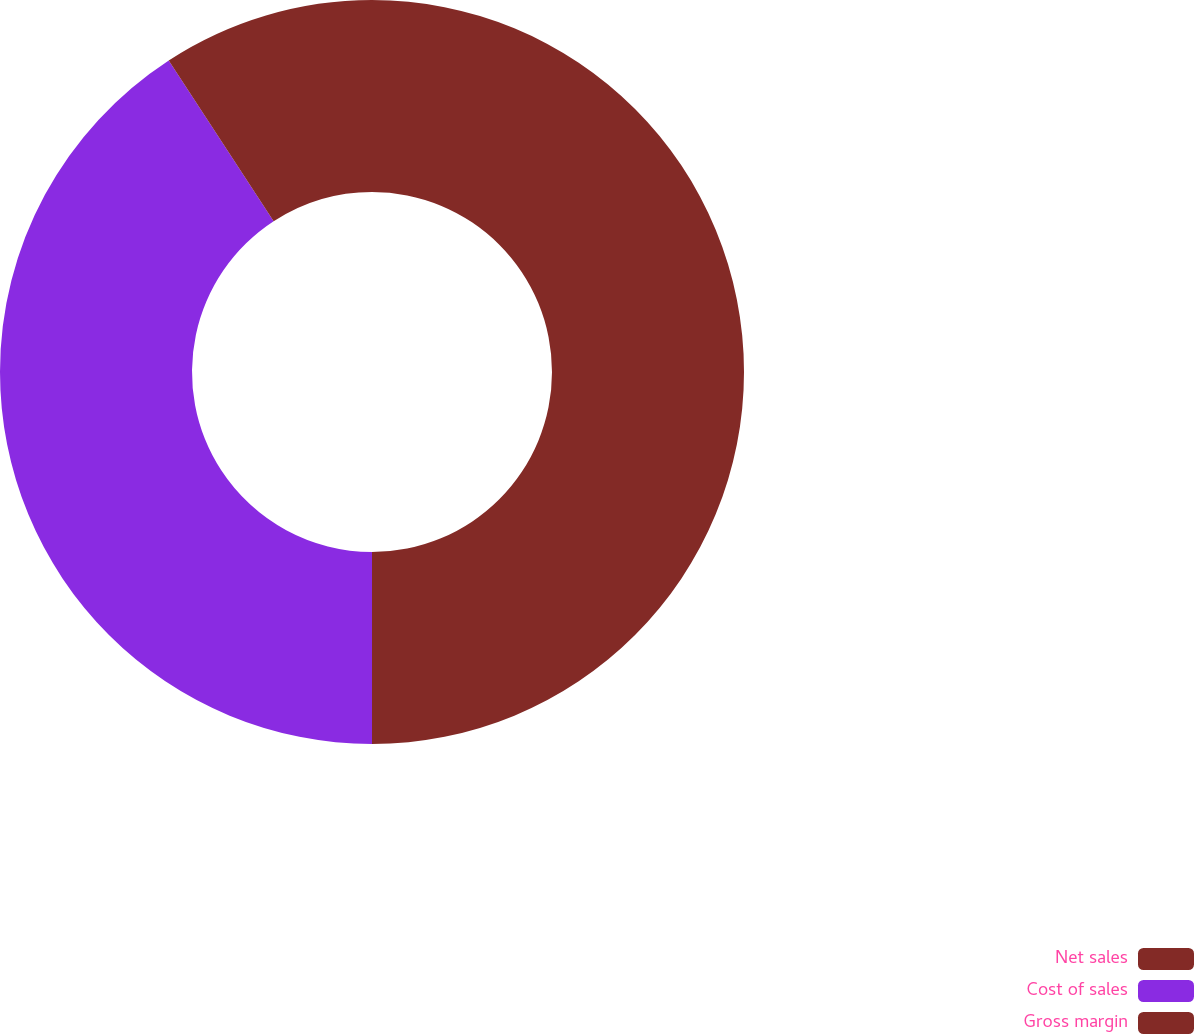<chart> <loc_0><loc_0><loc_500><loc_500><pie_chart><fcel>Net sales<fcel>Cost of sales<fcel>Gross margin<nl><fcel>50.0%<fcel>40.8%<fcel>9.2%<nl></chart> 